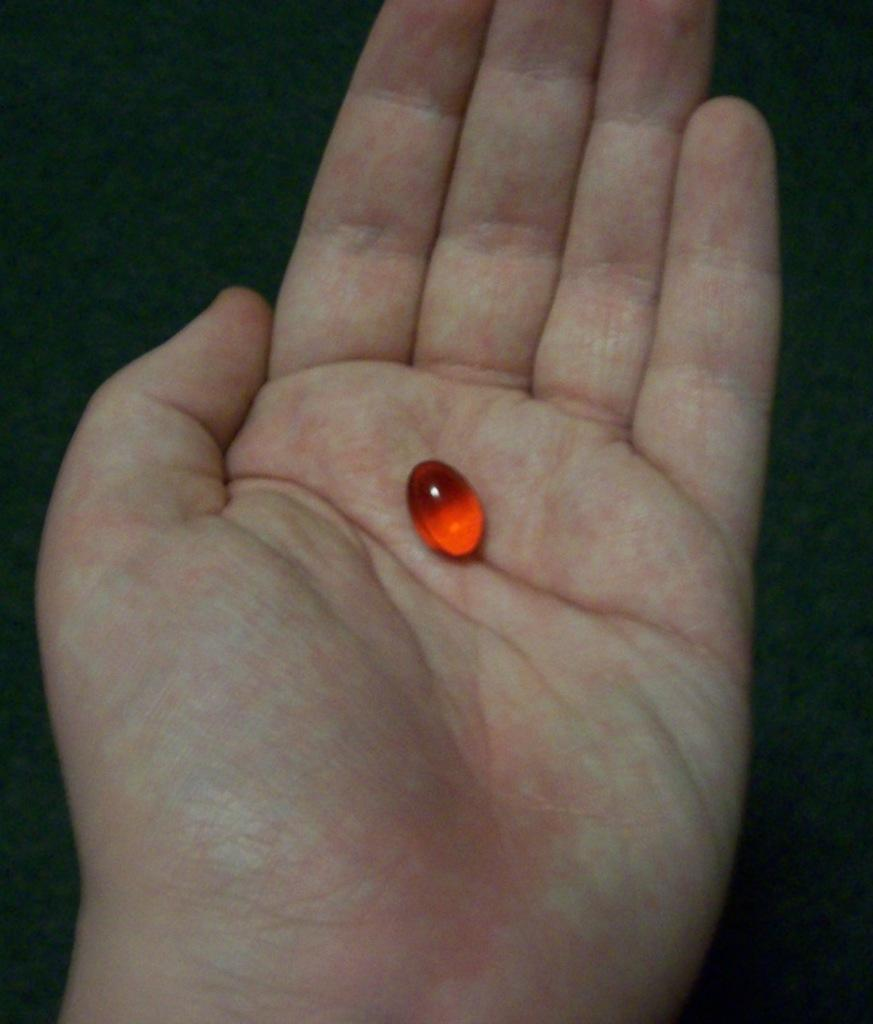What is the color of the small object in the image? The small object in the image is red. Where is the red object located? The red object is on the hand of a person. What can be observed about the background of the image? The background of the image is dark. What type of houses are visible in the image? There are no houses visible in the image; it only features a small red object on a person's hand and a dark background. What time of day is it in the image, based on the lunch hour? There is no indication of time or lunch hour in the image, as it only shows a small red object on a person's hand and a dark background. 